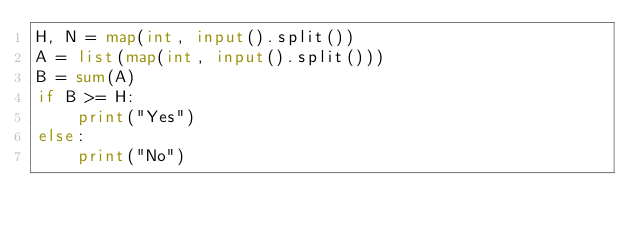Convert code to text. <code><loc_0><loc_0><loc_500><loc_500><_Python_>H, N = map(int, input().split())
A = list(map(int, input().split()))
B = sum(A)
if B >= H:
    print("Yes")
else:
    print("No")</code> 